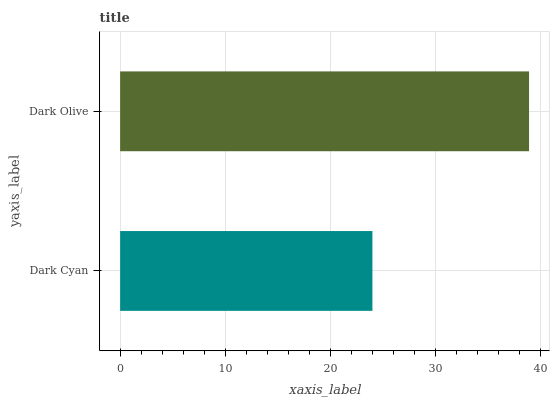Is Dark Cyan the minimum?
Answer yes or no. Yes. Is Dark Olive the maximum?
Answer yes or no. Yes. Is Dark Olive the minimum?
Answer yes or no. No. Is Dark Olive greater than Dark Cyan?
Answer yes or no. Yes. Is Dark Cyan less than Dark Olive?
Answer yes or no. Yes. Is Dark Cyan greater than Dark Olive?
Answer yes or no. No. Is Dark Olive less than Dark Cyan?
Answer yes or no. No. Is Dark Olive the high median?
Answer yes or no. Yes. Is Dark Cyan the low median?
Answer yes or no. Yes. Is Dark Cyan the high median?
Answer yes or no. No. Is Dark Olive the low median?
Answer yes or no. No. 